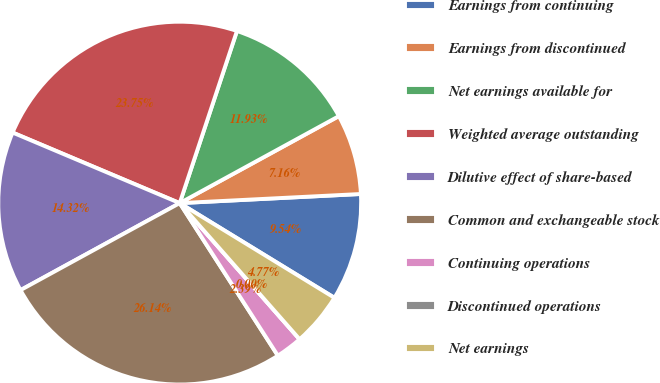Convert chart to OTSL. <chart><loc_0><loc_0><loc_500><loc_500><pie_chart><fcel>Earnings from continuing<fcel>Earnings from discontinued<fcel>Net earnings available for<fcel>Weighted average outstanding<fcel>Dilutive effect of share-based<fcel>Common and exchangeable stock<fcel>Continuing operations<fcel>Discontinued operations<fcel>Net earnings<nl><fcel>9.54%<fcel>7.16%<fcel>11.93%<fcel>23.75%<fcel>14.32%<fcel>26.14%<fcel>2.39%<fcel>0.0%<fcel>4.77%<nl></chart> 